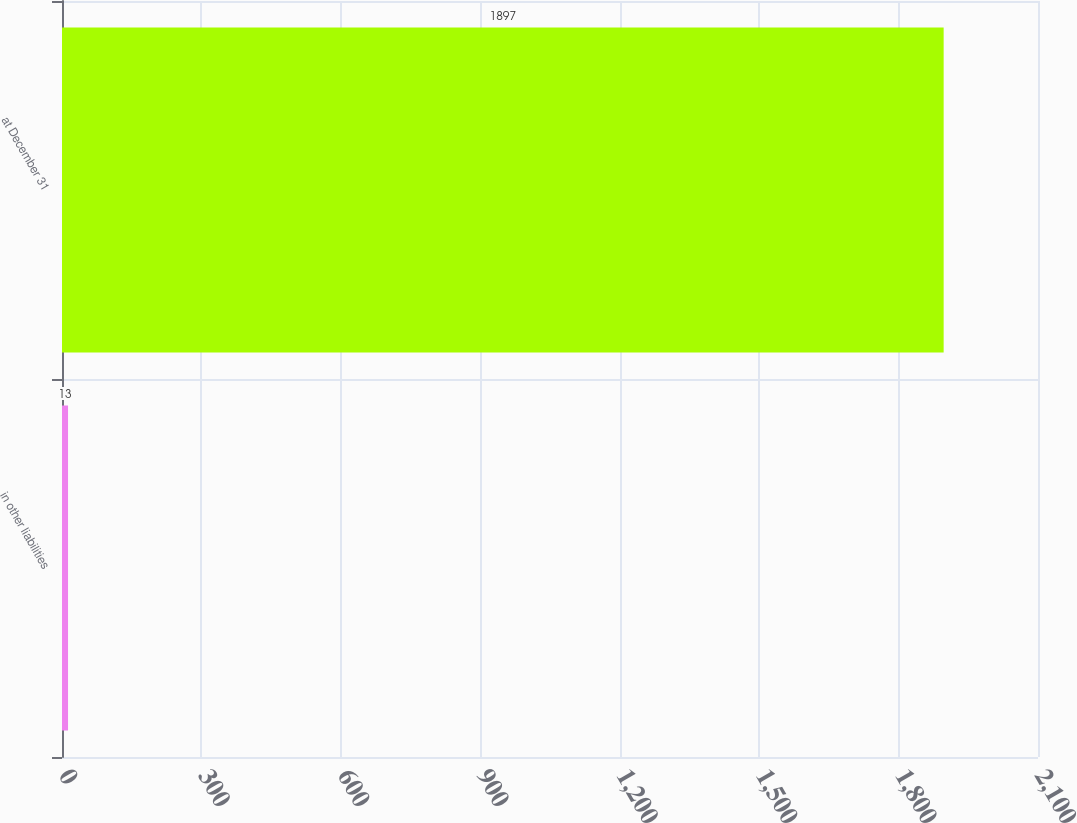<chart> <loc_0><loc_0><loc_500><loc_500><bar_chart><fcel>in other liabilities<fcel>at December 31<nl><fcel>13<fcel>1897<nl></chart> 